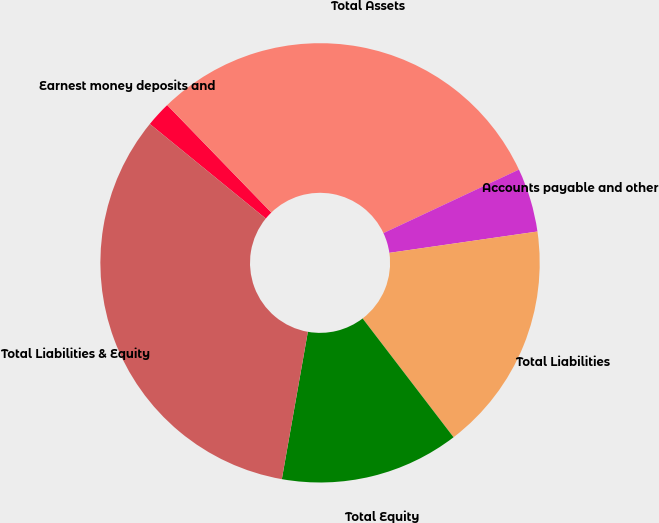<chart> <loc_0><loc_0><loc_500><loc_500><pie_chart><fcel>Earnest money deposits and<fcel>Total Assets<fcel>Accounts payable and other<fcel>Total Liabilities<fcel>Total Equity<fcel>Total Liabilities & Equity<nl><fcel>1.86%<fcel>30.27%<fcel>4.7%<fcel>16.88%<fcel>13.18%<fcel>33.11%<nl></chart> 